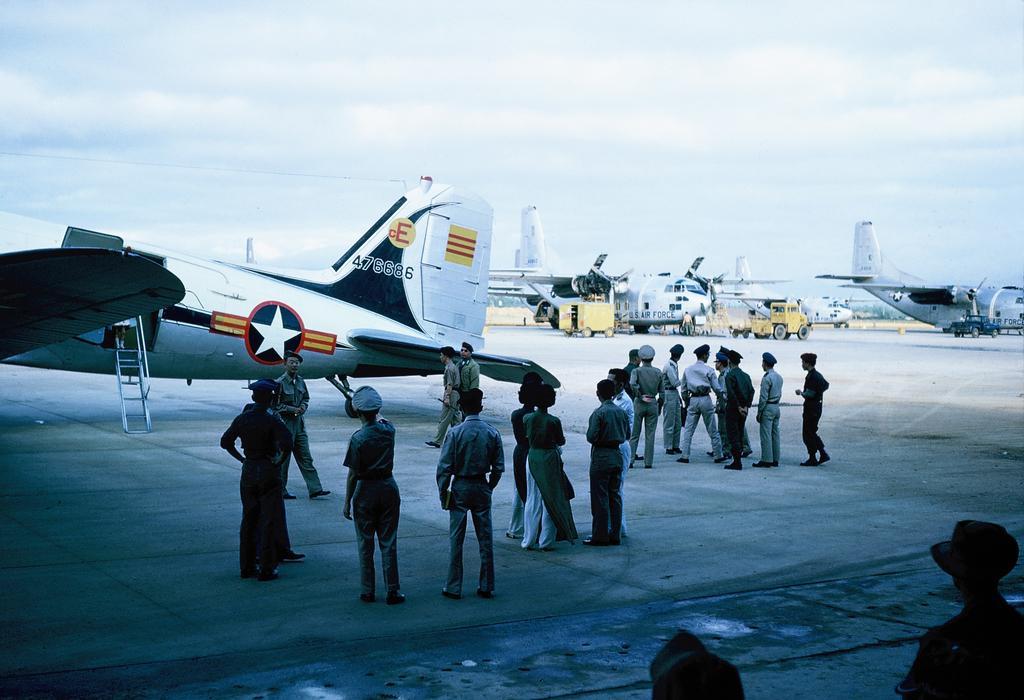Can you describe this image briefly? In this image we can see a group of people are standing, here are the airplanes on the runway, here are the vehicles, at above the sky is cloudy. 